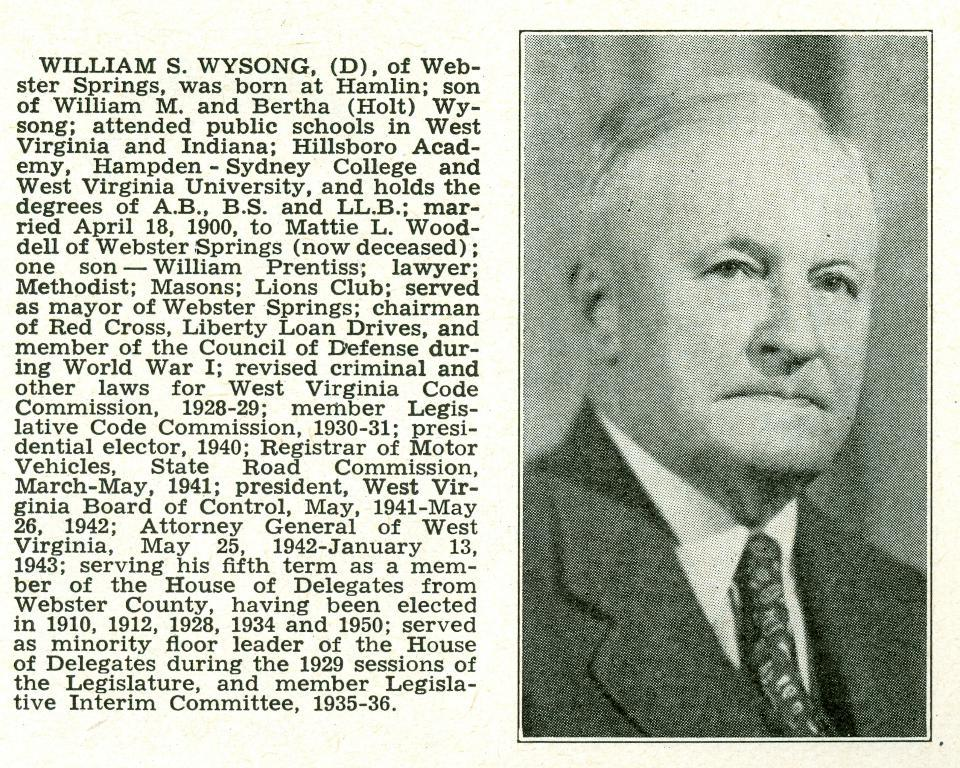Who or what is on the right side of the image? There is a person on the right side of the image. What else can be seen on the right side of the image besides the person? There is text on the right side of the image. Can you see a river flowing behind the person in the image? There is no river visible in the image; it only shows a person and text on the right side. 